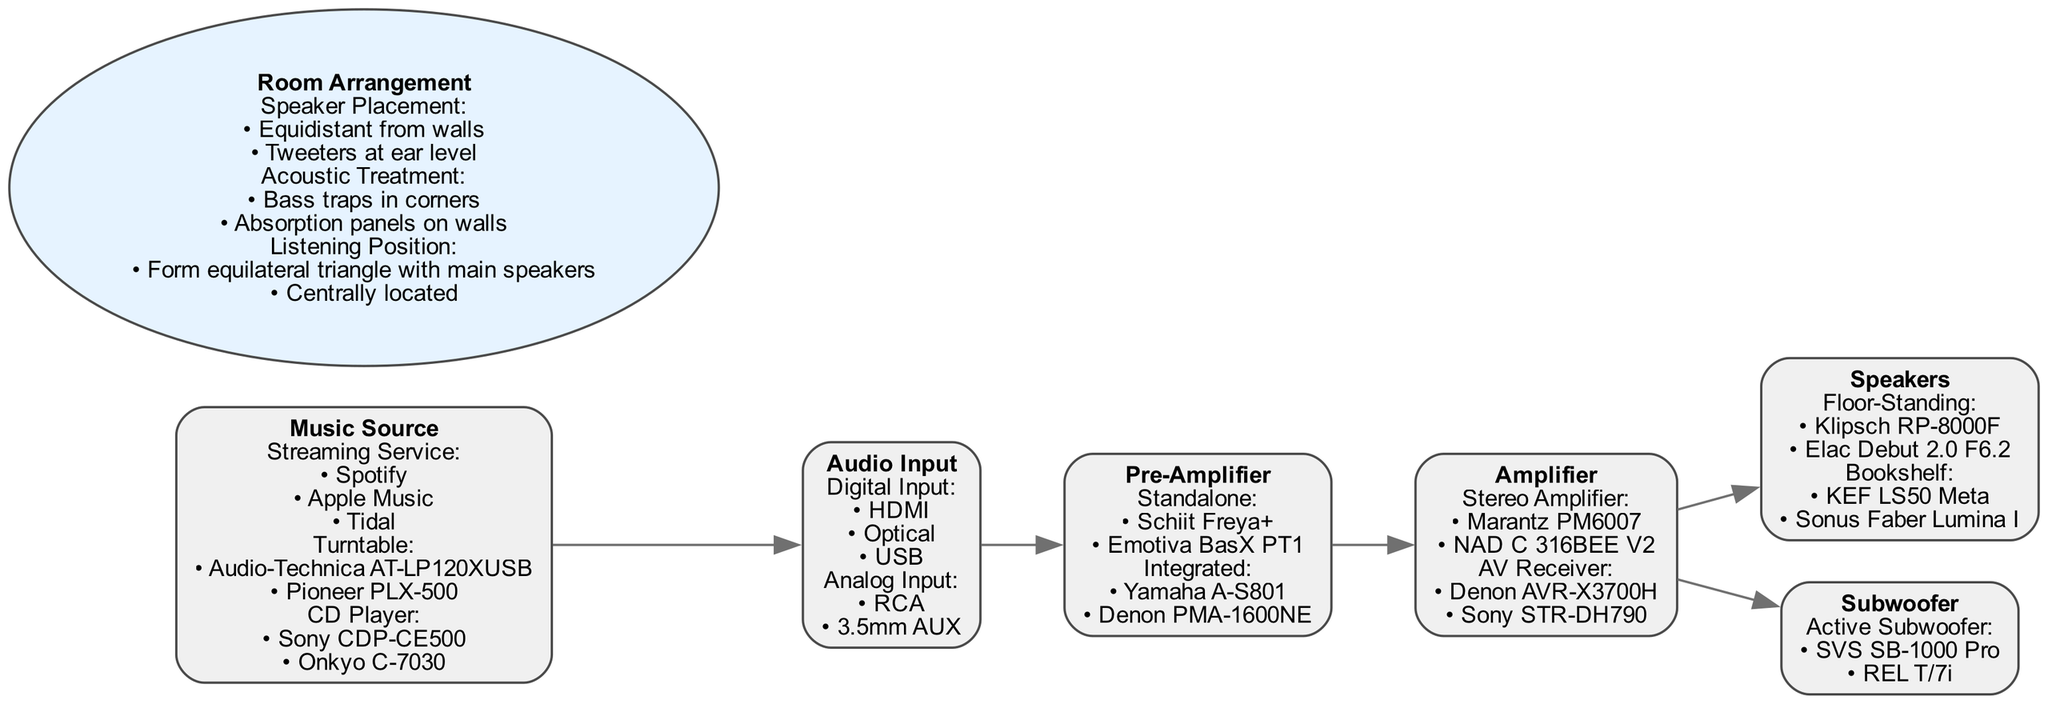What are the three types of music sources listed? The diagram shows three types of music sources: Streaming Service, Turntable, and CD Player.
Answer: Streaming Service, Turntable, CD Player How many different types of amplifiers are included? The diagram lists two types of amplifiers: Stereo Amplifier and AV Receiver, indicating there are two distinct categories of amplifiers present.
Answer: 2 What does 'Audio Input' connect to? In the flow of the diagram, 'Audio Input' directly connects to 'Pre-Amplifier', indicating this is the next step in the sound system setup after selecting audio input.
Answer: Pre-Amplifier Which speakers are listed under the 'Speakers' category? The 'Speakers' section includes two types: Floor-Standing and Bookshelf, which presents the categories of speakers available for the setup.
Answer: Floor-Standing, Bookshelf How is 'Room Arrangement' visually represented in the diagram? 'Room Arrangement' is represented as an ellipse shape in the diagram, which distinguishes it from the other rectangular nodes and suggests a different category related to room setup.
Answer: Ellipse What is the relationship between the 'Amplifier' and 'Speakers'? The 'Amplifier' directly connects to 'Speakers', indicating that the amplifier feeds audio signals into the speakers as part of the sound system structure.
Answer: Direct connection What specific options are available for the type of subwoofer? The diagram shows that the subwoofer has one type listed: Active Subwoofer, with the options being SVS SB-1000 Pro and REL T/7i, which indicates the available choices.
Answer: Active Subwoofer What placement is recommended for speakers according to the diagram's room arrangement section? The recommended placement for speakers is 'Equidistant from walls', which suggests an optimal positioning strategy for sound quality in the room setup.
Answer: Equidistant from walls Which music source type options are mentioned? The diagram outlines options for the music source which include Spotify, Apple Music, and Tidal under the Streaming Service category.
Answer: Spotify, Apple Music, Tidal 